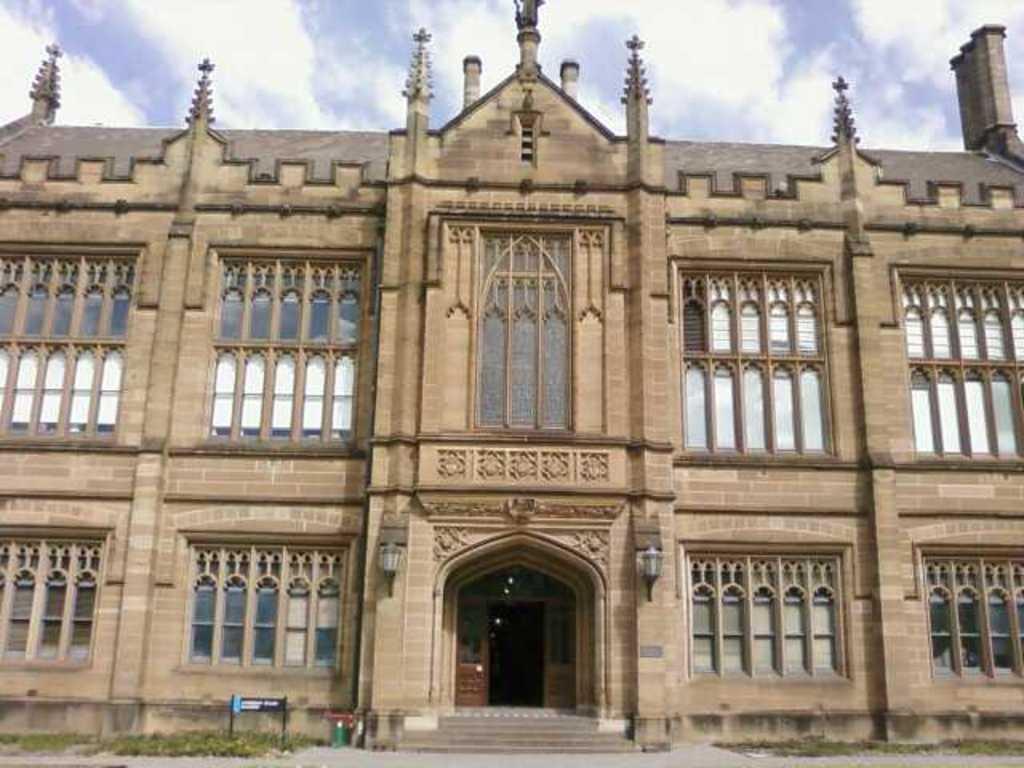How would you summarize this image in a sentence or two? In this image there is a building with the glass windows. At the bottom there is a door. On the floor there is some grass. At the top there is the sky. There is a board on the left side. 